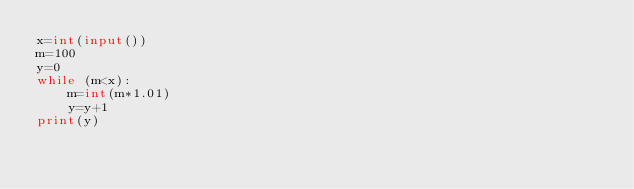Convert code to text. <code><loc_0><loc_0><loc_500><loc_500><_Python_>x=int(input())
m=100
y=0
while (m<x):
    m=int(m*1.01)
    y=y+1
print(y)</code> 